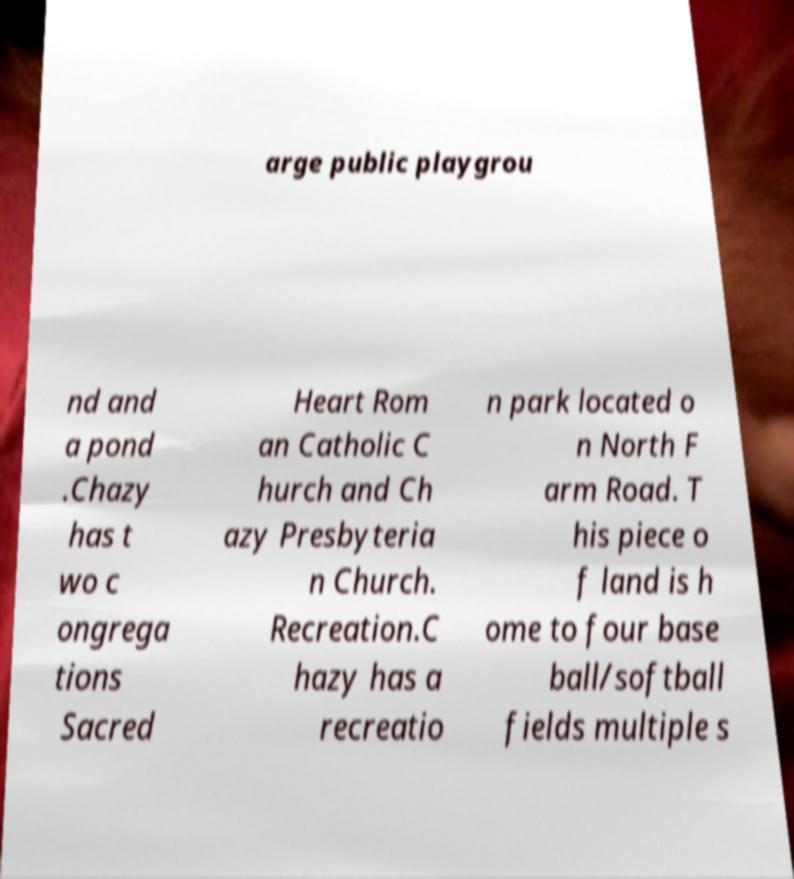Can you accurately transcribe the text from the provided image for me? arge public playgrou nd and a pond .Chazy has t wo c ongrega tions Sacred Heart Rom an Catholic C hurch and Ch azy Presbyteria n Church. Recreation.C hazy has a recreatio n park located o n North F arm Road. T his piece o f land is h ome to four base ball/softball fields multiple s 